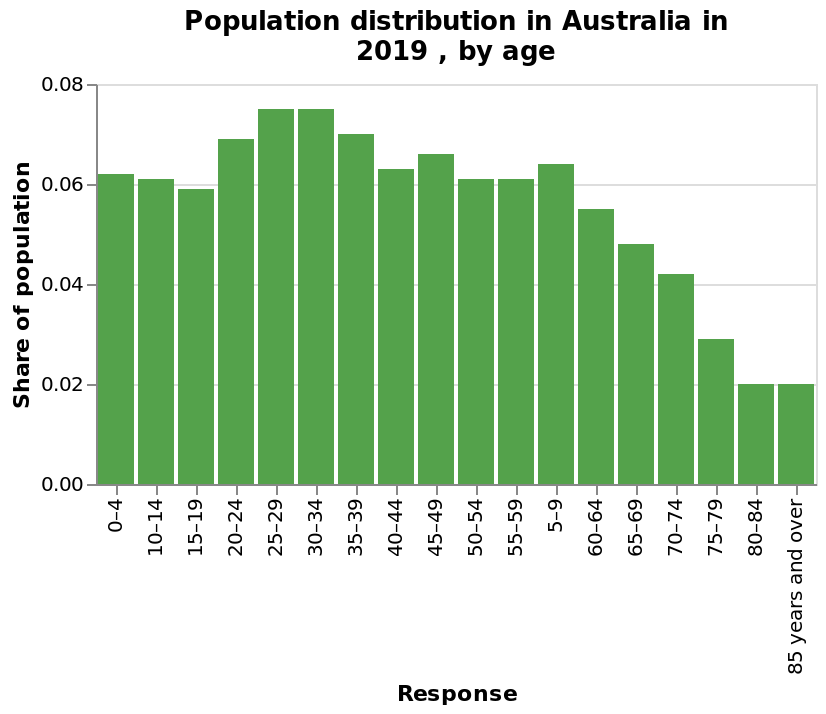<image>
What does the x-axis represent in the bar plot? The x-axis represents the response variable in the bar plot. Offer a thorough analysis of the image. The highest trend is for the 25 to 34 years as this is the peak and as you get older it drops off drmaitically. 